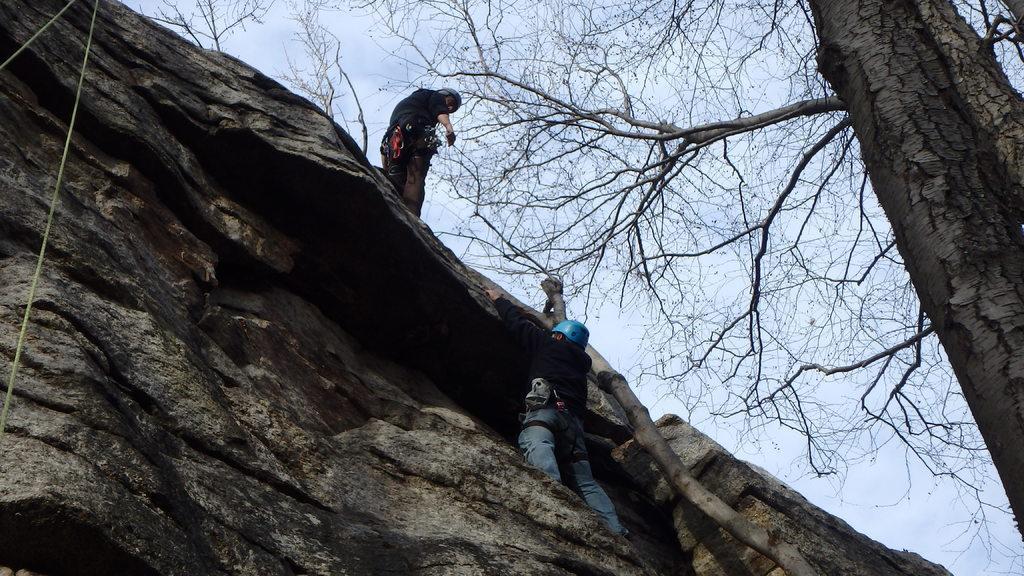Can you describe this image briefly? In this picture I can see there are two people climbing a mountain. This person is standing on the mountain and this person is climbing the mountain and in the backdrop I can see there is a tree and the sky is clear. 